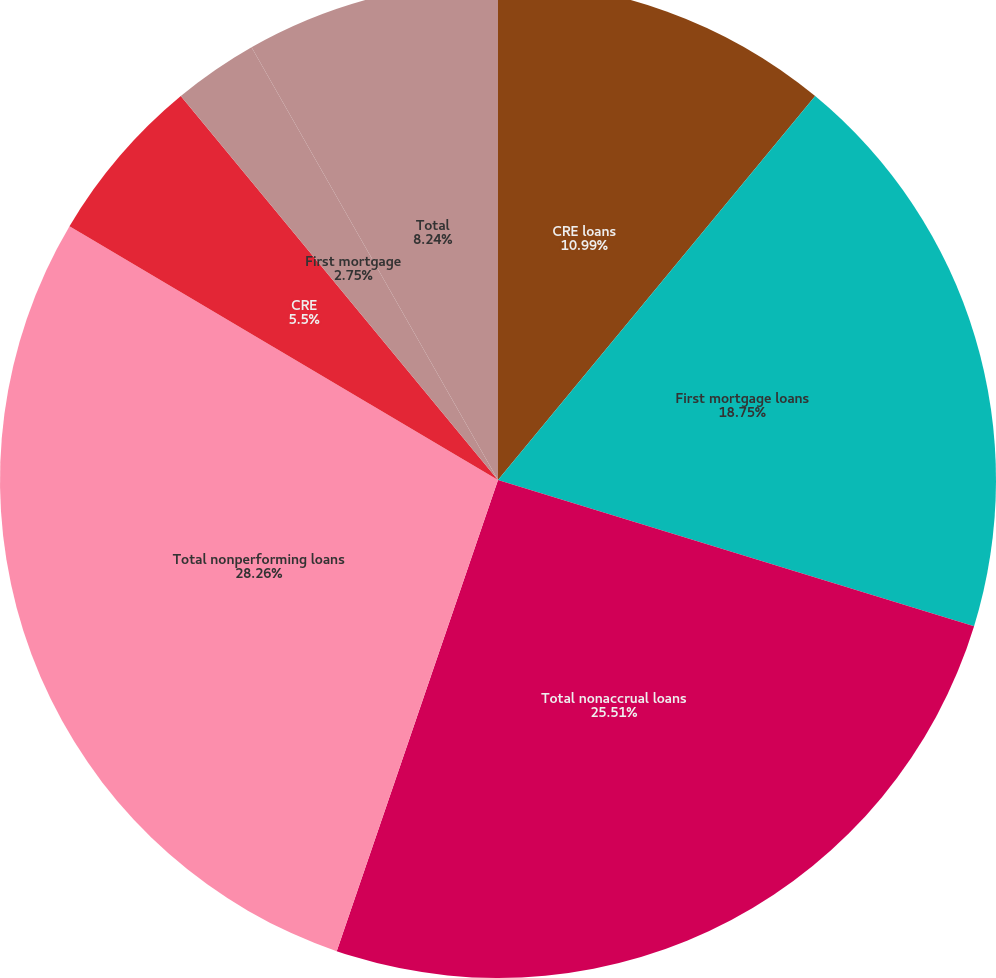Convert chart to OTSL. <chart><loc_0><loc_0><loc_500><loc_500><pie_chart><fcel>CRE loans<fcel>First mortgage loans<fcel>Total nonaccrual loans<fcel>Total nonperforming loans<fcel>CRE<fcel>First mortgage<fcel>Total<fcel>Total nonperforming assets net<nl><fcel>10.99%<fcel>18.75%<fcel>25.51%<fcel>28.26%<fcel>5.5%<fcel>2.75%<fcel>8.24%<fcel>0.0%<nl></chart> 